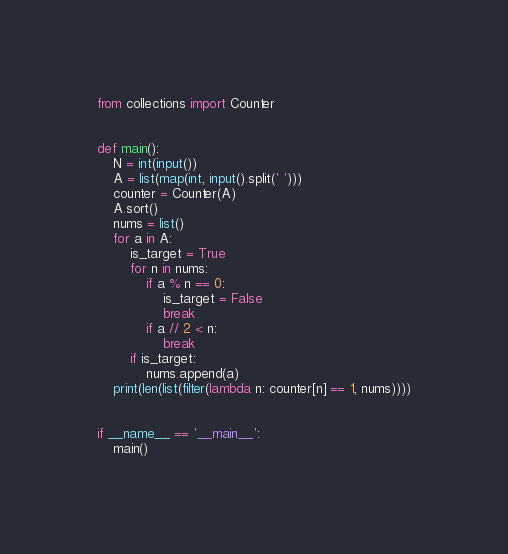<code> <loc_0><loc_0><loc_500><loc_500><_Python_>from collections import Counter


def main():
    N = int(input())
    A = list(map(int, input().split(' ')))
    counter = Counter(A)
    A.sort()
    nums = list()
    for a in A:
        is_target = True
        for n in nums:
            if a % n == 0:
                is_target = False
                break
            if a // 2 < n:
                break
        if is_target:
            nums.append(a)
    print(len(list(filter(lambda n: counter[n] == 1, nums))))


if __name__ == '__main__':
    main()</code> 